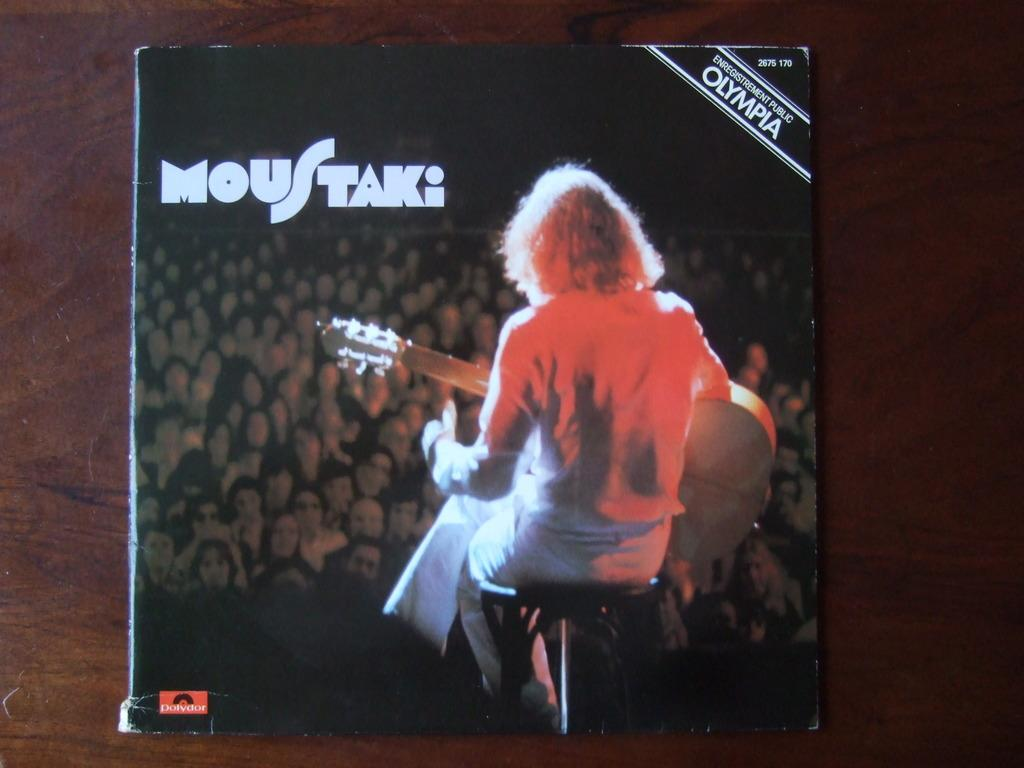What is the main object in the image? There is a book in the image. What is the book placed on? The book is on a wooden board. What types of content can be found on the book? There are words, numbers, and a photo on the book. What type of yarn is being used to exchange information on the book? There is no yarn present in the image, and the book does not involve any exchange of information. 